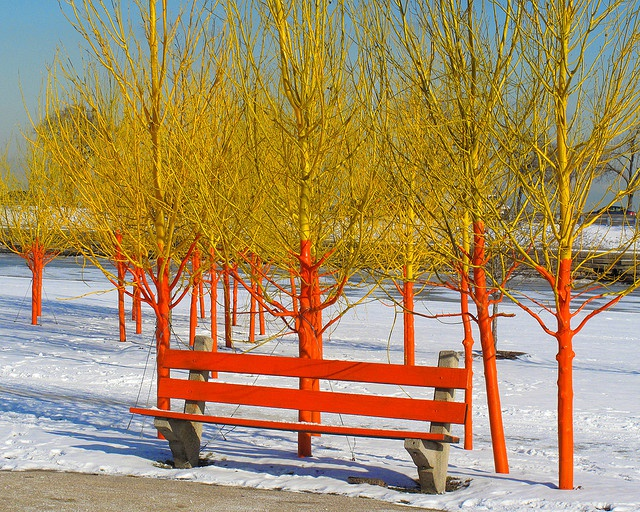Describe the objects in this image and their specific colors. I can see a bench in lightblue, red, lightgray, darkgray, and black tones in this image. 